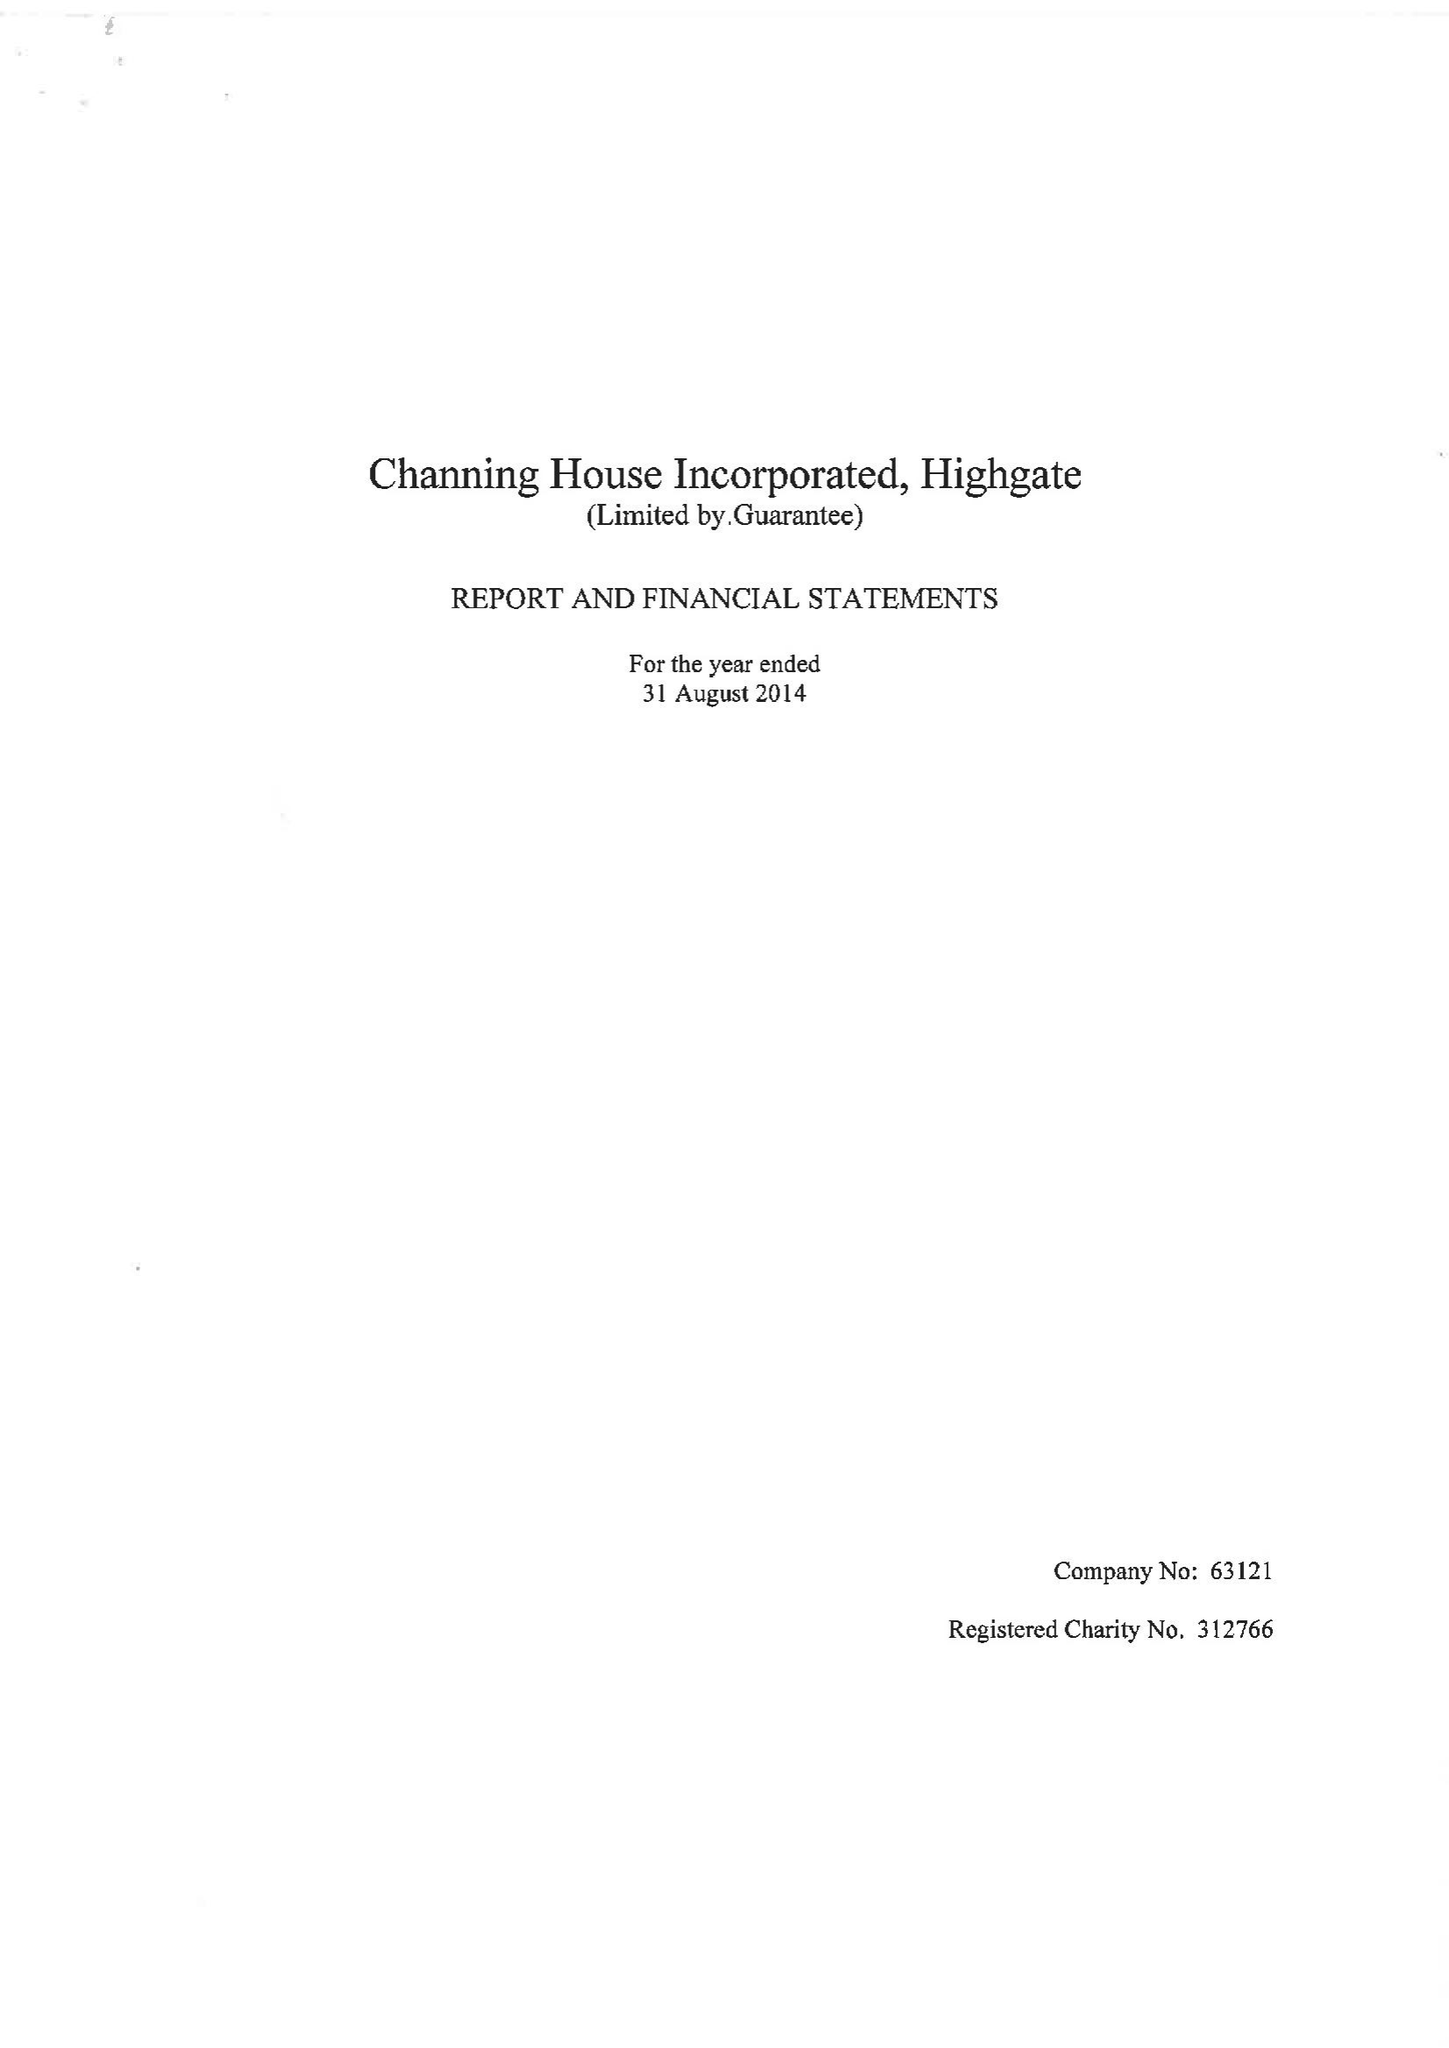What is the value for the charity_name?
Answer the question using a single word or phrase. Channing House Inc. 